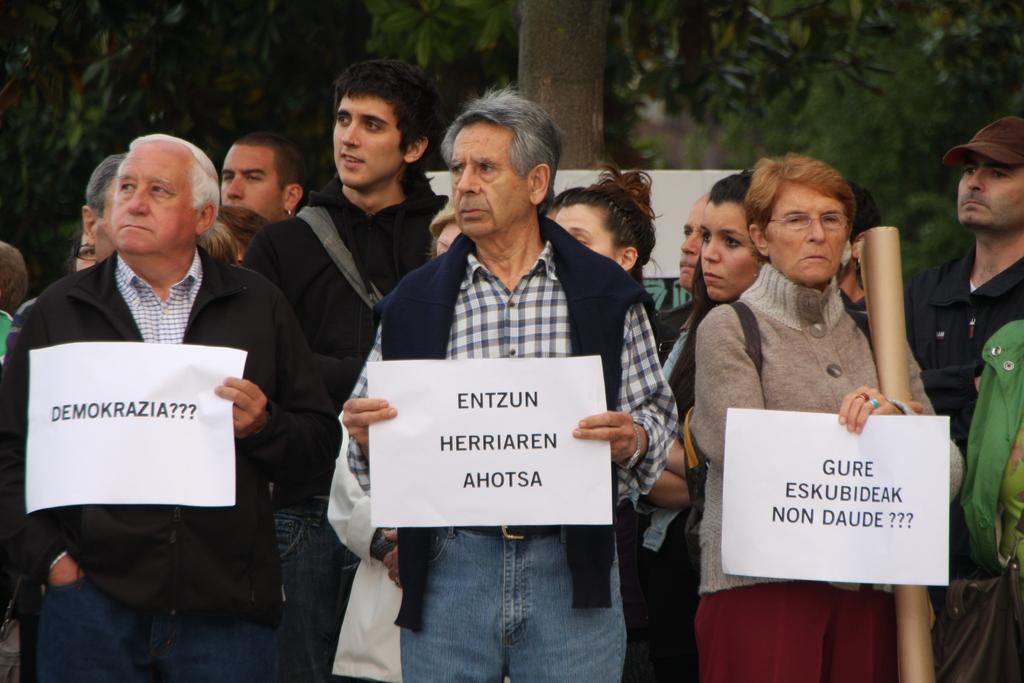In one or two sentences, can you explain what this image depicts? In this image I can see a group of people are standing on the road and are holding posters in their hand. In the background I can see trees. This image is taken may be during a day. 